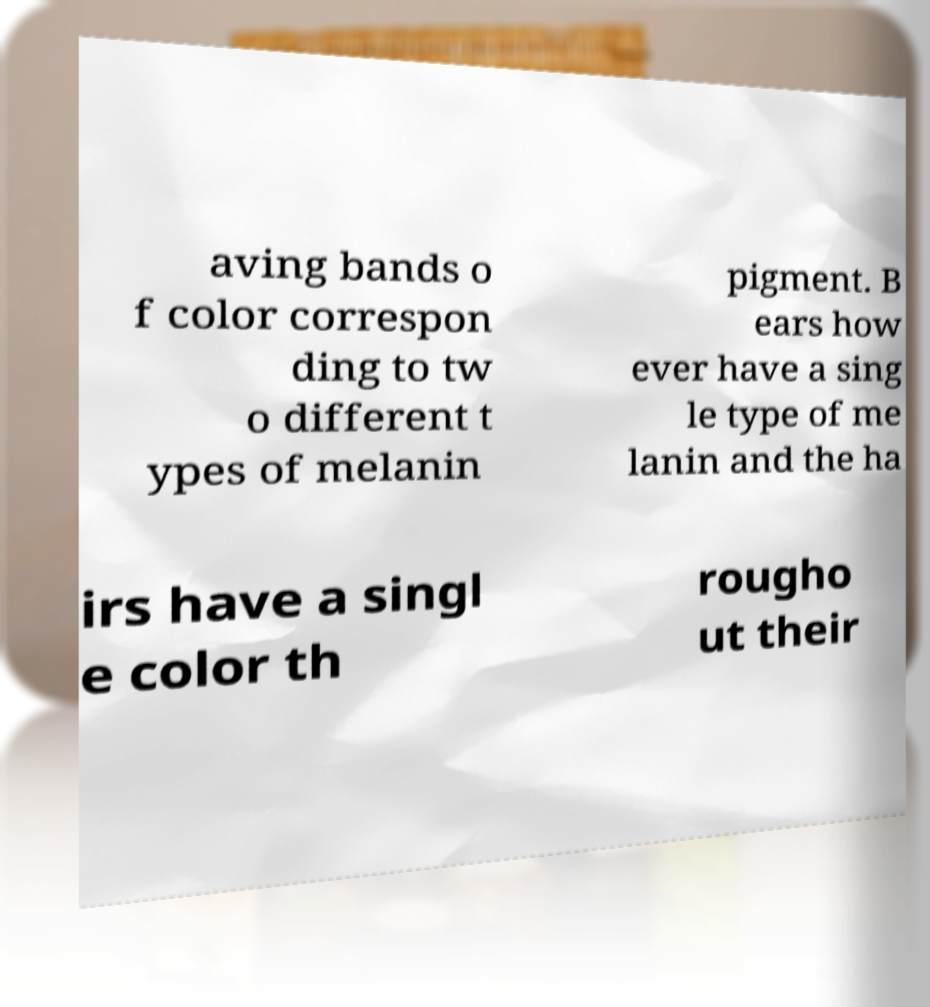I need the written content from this picture converted into text. Can you do that? aving bands o f color correspon ding to tw o different t ypes of melanin pigment. B ears how ever have a sing le type of me lanin and the ha irs have a singl e color th rougho ut their 